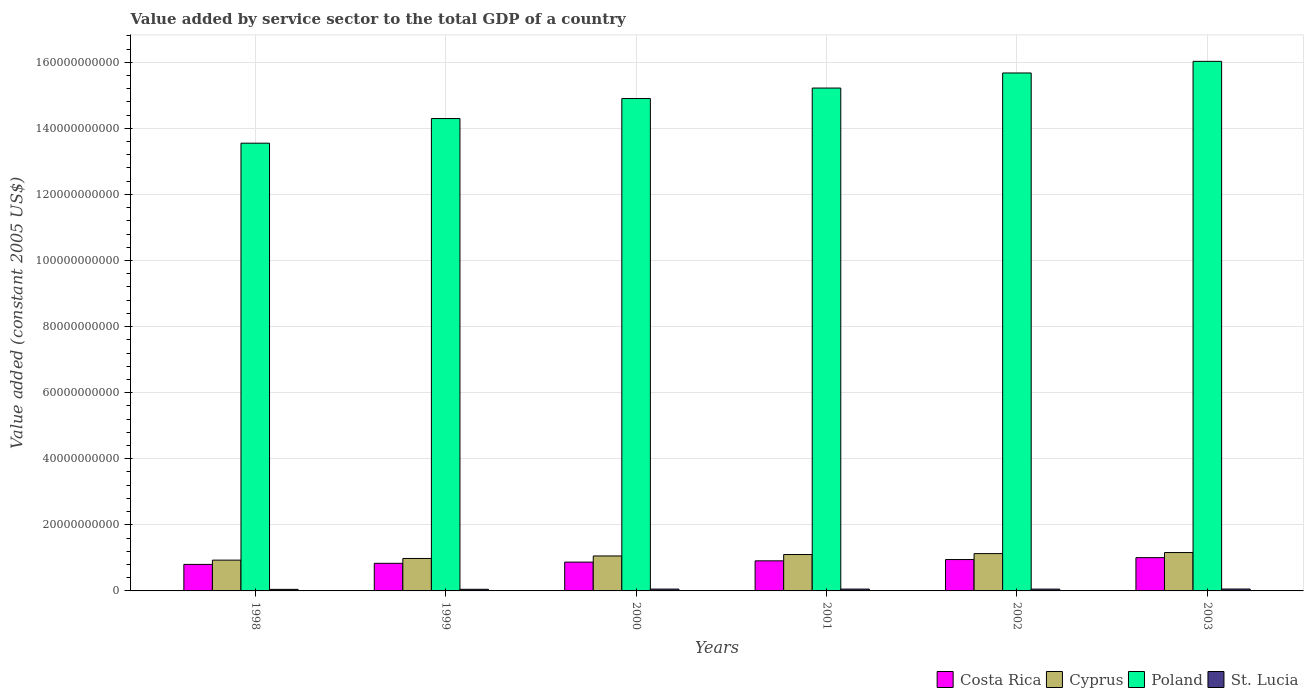Are the number of bars per tick equal to the number of legend labels?
Your answer should be compact. Yes. How many bars are there on the 4th tick from the left?
Ensure brevity in your answer.  4. How many bars are there on the 2nd tick from the right?
Your answer should be very brief. 4. What is the value added by service sector in Costa Rica in 2001?
Your response must be concise. 9.11e+09. Across all years, what is the maximum value added by service sector in Costa Rica?
Give a very brief answer. 1.01e+1. Across all years, what is the minimum value added by service sector in Poland?
Provide a succinct answer. 1.36e+11. In which year was the value added by service sector in Costa Rica minimum?
Your answer should be very brief. 1998. What is the total value added by service sector in Poland in the graph?
Provide a short and direct response. 8.97e+11. What is the difference between the value added by service sector in St. Lucia in 2000 and that in 2001?
Your response must be concise. -4.09e+06. What is the difference between the value added by service sector in Costa Rica in 1998 and the value added by service sector in Poland in 2001?
Offer a very short reply. -1.44e+11. What is the average value added by service sector in Costa Rica per year?
Keep it short and to the point. 8.96e+09. In the year 2002, what is the difference between the value added by service sector in St. Lucia and value added by service sector in Costa Rica?
Keep it short and to the point. -8.95e+09. In how many years, is the value added by service sector in St. Lucia greater than 12000000000 US$?
Provide a short and direct response. 0. What is the ratio of the value added by service sector in St. Lucia in 2000 to that in 2002?
Your response must be concise. 1.01. Is the difference between the value added by service sector in St. Lucia in 1999 and 2001 greater than the difference between the value added by service sector in Costa Rica in 1999 and 2001?
Ensure brevity in your answer.  Yes. What is the difference between the highest and the second highest value added by service sector in Costa Rica?
Your answer should be compact. 5.77e+08. What is the difference between the highest and the lowest value added by service sector in Costa Rica?
Your answer should be very brief. 2.04e+09. Is the sum of the value added by service sector in St. Lucia in 1998 and 2000 greater than the maximum value added by service sector in Poland across all years?
Provide a succinct answer. No. What does the 2nd bar from the right in 2003 represents?
Your response must be concise. Poland. How many bars are there?
Offer a very short reply. 24. Are all the bars in the graph horizontal?
Offer a very short reply. No. What is the difference between two consecutive major ticks on the Y-axis?
Your answer should be very brief. 2.00e+1. Are the values on the major ticks of Y-axis written in scientific E-notation?
Your answer should be very brief. No. Where does the legend appear in the graph?
Your answer should be very brief. Bottom right. How many legend labels are there?
Give a very brief answer. 4. What is the title of the graph?
Provide a short and direct response. Value added by service sector to the total GDP of a country. Does "East Asia (all income levels)" appear as one of the legend labels in the graph?
Give a very brief answer. No. What is the label or title of the Y-axis?
Offer a terse response. Value added (constant 2005 US$). What is the Value added (constant 2005 US$) of Costa Rica in 1998?
Your answer should be very brief. 8.03e+09. What is the Value added (constant 2005 US$) in Cyprus in 1998?
Your response must be concise. 9.32e+09. What is the Value added (constant 2005 US$) in Poland in 1998?
Ensure brevity in your answer.  1.36e+11. What is the Value added (constant 2005 US$) in St. Lucia in 1998?
Keep it short and to the point. 4.72e+08. What is the Value added (constant 2005 US$) in Costa Rica in 1999?
Your response must be concise. 8.36e+09. What is the Value added (constant 2005 US$) in Cyprus in 1999?
Provide a short and direct response. 9.83e+09. What is the Value added (constant 2005 US$) of Poland in 1999?
Offer a terse response. 1.43e+11. What is the Value added (constant 2005 US$) of St. Lucia in 1999?
Your answer should be compact. 4.93e+08. What is the Value added (constant 2005 US$) of Costa Rica in 2000?
Provide a succinct answer. 8.72e+09. What is the Value added (constant 2005 US$) of Cyprus in 2000?
Keep it short and to the point. 1.06e+1. What is the Value added (constant 2005 US$) in Poland in 2000?
Give a very brief answer. 1.49e+11. What is the Value added (constant 2005 US$) of St. Lucia in 2000?
Your answer should be compact. 5.53e+08. What is the Value added (constant 2005 US$) in Costa Rica in 2001?
Offer a terse response. 9.11e+09. What is the Value added (constant 2005 US$) in Cyprus in 2001?
Offer a terse response. 1.10e+1. What is the Value added (constant 2005 US$) in Poland in 2001?
Your answer should be very brief. 1.52e+11. What is the Value added (constant 2005 US$) in St. Lucia in 2001?
Offer a very short reply. 5.57e+08. What is the Value added (constant 2005 US$) of Costa Rica in 2002?
Give a very brief answer. 9.49e+09. What is the Value added (constant 2005 US$) of Cyprus in 2002?
Your response must be concise. 1.13e+1. What is the Value added (constant 2005 US$) in Poland in 2002?
Keep it short and to the point. 1.57e+11. What is the Value added (constant 2005 US$) in St. Lucia in 2002?
Your response must be concise. 5.46e+08. What is the Value added (constant 2005 US$) in Costa Rica in 2003?
Your answer should be very brief. 1.01e+1. What is the Value added (constant 2005 US$) of Cyprus in 2003?
Provide a short and direct response. 1.16e+1. What is the Value added (constant 2005 US$) of Poland in 2003?
Your response must be concise. 1.60e+11. What is the Value added (constant 2005 US$) in St. Lucia in 2003?
Offer a very short reply. 5.74e+08. Across all years, what is the maximum Value added (constant 2005 US$) in Costa Rica?
Your response must be concise. 1.01e+1. Across all years, what is the maximum Value added (constant 2005 US$) of Cyprus?
Your answer should be compact. 1.16e+1. Across all years, what is the maximum Value added (constant 2005 US$) in Poland?
Offer a very short reply. 1.60e+11. Across all years, what is the maximum Value added (constant 2005 US$) of St. Lucia?
Ensure brevity in your answer.  5.74e+08. Across all years, what is the minimum Value added (constant 2005 US$) in Costa Rica?
Provide a short and direct response. 8.03e+09. Across all years, what is the minimum Value added (constant 2005 US$) of Cyprus?
Give a very brief answer. 9.32e+09. Across all years, what is the minimum Value added (constant 2005 US$) of Poland?
Offer a terse response. 1.36e+11. Across all years, what is the minimum Value added (constant 2005 US$) of St. Lucia?
Ensure brevity in your answer.  4.72e+08. What is the total Value added (constant 2005 US$) in Costa Rica in the graph?
Offer a terse response. 5.38e+1. What is the total Value added (constant 2005 US$) in Cyprus in the graph?
Provide a short and direct response. 6.36e+1. What is the total Value added (constant 2005 US$) in Poland in the graph?
Your answer should be compact. 8.97e+11. What is the total Value added (constant 2005 US$) of St. Lucia in the graph?
Your answer should be compact. 3.20e+09. What is the difference between the Value added (constant 2005 US$) in Costa Rica in 1998 and that in 1999?
Your answer should be compact. -3.30e+08. What is the difference between the Value added (constant 2005 US$) in Cyprus in 1998 and that in 1999?
Your response must be concise. -5.08e+08. What is the difference between the Value added (constant 2005 US$) of Poland in 1998 and that in 1999?
Your response must be concise. -7.45e+09. What is the difference between the Value added (constant 2005 US$) of St. Lucia in 1998 and that in 1999?
Provide a succinct answer. -2.10e+07. What is the difference between the Value added (constant 2005 US$) in Costa Rica in 1998 and that in 2000?
Offer a terse response. -6.91e+08. What is the difference between the Value added (constant 2005 US$) in Cyprus in 1998 and that in 2000?
Offer a very short reply. -1.26e+09. What is the difference between the Value added (constant 2005 US$) in Poland in 1998 and that in 2000?
Your response must be concise. -1.35e+1. What is the difference between the Value added (constant 2005 US$) of St. Lucia in 1998 and that in 2000?
Keep it short and to the point. -8.11e+07. What is the difference between the Value added (constant 2005 US$) in Costa Rica in 1998 and that in 2001?
Give a very brief answer. -1.08e+09. What is the difference between the Value added (constant 2005 US$) in Cyprus in 1998 and that in 2001?
Make the answer very short. -1.70e+09. What is the difference between the Value added (constant 2005 US$) of Poland in 1998 and that in 2001?
Give a very brief answer. -1.67e+1. What is the difference between the Value added (constant 2005 US$) in St. Lucia in 1998 and that in 2001?
Keep it short and to the point. -8.52e+07. What is the difference between the Value added (constant 2005 US$) in Costa Rica in 1998 and that in 2002?
Your answer should be very brief. -1.46e+09. What is the difference between the Value added (constant 2005 US$) in Cyprus in 1998 and that in 2002?
Offer a terse response. -1.98e+09. What is the difference between the Value added (constant 2005 US$) of Poland in 1998 and that in 2002?
Your answer should be very brief. -2.12e+1. What is the difference between the Value added (constant 2005 US$) in St. Lucia in 1998 and that in 2002?
Your answer should be very brief. -7.44e+07. What is the difference between the Value added (constant 2005 US$) in Costa Rica in 1998 and that in 2003?
Offer a terse response. -2.04e+09. What is the difference between the Value added (constant 2005 US$) in Cyprus in 1998 and that in 2003?
Provide a succinct answer. -2.30e+09. What is the difference between the Value added (constant 2005 US$) of Poland in 1998 and that in 2003?
Your answer should be compact. -2.48e+1. What is the difference between the Value added (constant 2005 US$) in St. Lucia in 1998 and that in 2003?
Your response must be concise. -1.02e+08. What is the difference between the Value added (constant 2005 US$) in Costa Rica in 1999 and that in 2000?
Your answer should be very brief. -3.61e+08. What is the difference between the Value added (constant 2005 US$) of Cyprus in 1999 and that in 2000?
Offer a very short reply. -7.54e+08. What is the difference between the Value added (constant 2005 US$) in Poland in 1999 and that in 2000?
Keep it short and to the point. -6.06e+09. What is the difference between the Value added (constant 2005 US$) in St. Lucia in 1999 and that in 2000?
Offer a terse response. -6.01e+07. What is the difference between the Value added (constant 2005 US$) of Costa Rica in 1999 and that in 2001?
Ensure brevity in your answer.  -7.47e+08. What is the difference between the Value added (constant 2005 US$) of Cyprus in 1999 and that in 2001?
Give a very brief answer. -1.19e+09. What is the difference between the Value added (constant 2005 US$) in Poland in 1999 and that in 2001?
Keep it short and to the point. -9.23e+09. What is the difference between the Value added (constant 2005 US$) in St. Lucia in 1999 and that in 2001?
Give a very brief answer. -6.42e+07. What is the difference between the Value added (constant 2005 US$) of Costa Rica in 1999 and that in 2002?
Your answer should be compact. -1.13e+09. What is the difference between the Value added (constant 2005 US$) in Cyprus in 1999 and that in 2002?
Your answer should be very brief. -1.47e+09. What is the difference between the Value added (constant 2005 US$) of Poland in 1999 and that in 2002?
Provide a short and direct response. -1.38e+1. What is the difference between the Value added (constant 2005 US$) in St. Lucia in 1999 and that in 2002?
Provide a short and direct response. -5.34e+07. What is the difference between the Value added (constant 2005 US$) in Costa Rica in 1999 and that in 2003?
Offer a very short reply. -1.71e+09. What is the difference between the Value added (constant 2005 US$) in Cyprus in 1999 and that in 2003?
Offer a terse response. -1.79e+09. What is the difference between the Value added (constant 2005 US$) in Poland in 1999 and that in 2003?
Provide a short and direct response. -1.73e+1. What is the difference between the Value added (constant 2005 US$) in St. Lucia in 1999 and that in 2003?
Provide a short and direct response. -8.07e+07. What is the difference between the Value added (constant 2005 US$) in Costa Rica in 2000 and that in 2001?
Your answer should be compact. -3.86e+08. What is the difference between the Value added (constant 2005 US$) of Cyprus in 2000 and that in 2001?
Give a very brief answer. -4.37e+08. What is the difference between the Value added (constant 2005 US$) in Poland in 2000 and that in 2001?
Your answer should be very brief. -3.17e+09. What is the difference between the Value added (constant 2005 US$) in St. Lucia in 2000 and that in 2001?
Your response must be concise. -4.09e+06. What is the difference between the Value added (constant 2005 US$) in Costa Rica in 2000 and that in 2002?
Give a very brief answer. -7.73e+08. What is the difference between the Value added (constant 2005 US$) of Cyprus in 2000 and that in 2002?
Keep it short and to the point. -7.16e+08. What is the difference between the Value added (constant 2005 US$) in Poland in 2000 and that in 2002?
Provide a short and direct response. -7.74e+09. What is the difference between the Value added (constant 2005 US$) in St. Lucia in 2000 and that in 2002?
Your response must be concise. 6.70e+06. What is the difference between the Value added (constant 2005 US$) of Costa Rica in 2000 and that in 2003?
Your response must be concise. -1.35e+09. What is the difference between the Value added (constant 2005 US$) of Cyprus in 2000 and that in 2003?
Offer a terse response. -1.04e+09. What is the difference between the Value added (constant 2005 US$) in Poland in 2000 and that in 2003?
Make the answer very short. -1.13e+1. What is the difference between the Value added (constant 2005 US$) in St. Lucia in 2000 and that in 2003?
Your answer should be very brief. -2.07e+07. What is the difference between the Value added (constant 2005 US$) of Costa Rica in 2001 and that in 2002?
Keep it short and to the point. -3.86e+08. What is the difference between the Value added (constant 2005 US$) in Cyprus in 2001 and that in 2002?
Give a very brief answer. -2.79e+08. What is the difference between the Value added (constant 2005 US$) of Poland in 2001 and that in 2002?
Provide a short and direct response. -4.56e+09. What is the difference between the Value added (constant 2005 US$) of St. Lucia in 2001 and that in 2002?
Offer a very short reply. 1.08e+07. What is the difference between the Value added (constant 2005 US$) in Costa Rica in 2001 and that in 2003?
Keep it short and to the point. -9.63e+08. What is the difference between the Value added (constant 2005 US$) of Cyprus in 2001 and that in 2003?
Your answer should be compact. -6.00e+08. What is the difference between the Value added (constant 2005 US$) in Poland in 2001 and that in 2003?
Make the answer very short. -8.08e+09. What is the difference between the Value added (constant 2005 US$) of St. Lucia in 2001 and that in 2003?
Keep it short and to the point. -1.66e+07. What is the difference between the Value added (constant 2005 US$) of Costa Rica in 2002 and that in 2003?
Provide a short and direct response. -5.77e+08. What is the difference between the Value added (constant 2005 US$) in Cyprus in 2002 and that in 2003?
Your answer should be very brief. -3.21e+08. What is the difference between the Value added (constant 2005 US$) in Poland in 2002 and that in 2003?
Ensure brevity in your answer.  -3.52e+09. What is the difference between the Value added (constant 2005 US$) of St. Lucia in 2002 and that in 2003?
Your answer should be very brief. -2.74e+07. What is the difference between the Value added (constant 2005 US$) in Costa Rica in 1998 and the Value added (constant 2005 US$) in Cyprus in 1999?
Provide a short and direct response. -1.80e+09. What is the difference between the Value added (constant 2005 US$) in Costa Rica in 1998 and the Value added (constant 2005 US$) in Poland in 1999?
Your answer should be very brief. -1.35e+11. What is the difference between the Value added (constant 2005 US$) of Costa Rica in 1998 and the Value added (constant 2005 US$) of St. Lucia in 1999?
Make the answer very short. 7.54e+09. What is the difference between the Value added (constant 2005 US$) in Cyprus in 1998 and the Value added (constant 2005 US$) in Poland in 1999?
Ensure brevity in your answer.  -1.34e+11. What is the difference between the Value added (constant 2005 US$) of Cyprus in 1998 and the Value added (constant 2005 US$) of St. Lucia in 1999?
Provide a short and direct response. 8.82e+09. What is the difference between the Value added (constant 2005 US$) in Poland in 1998 and the Value added (constant 2005 US$) in St. Lucia in 1999?
Make the answer very short. 1.35e+11. What is the difference between the Value added (constant 2005 US$) in Costa Rica in 1998 and the Value added (constant 2005 US$) in Cyprus in 2000?
Offer a terse response. -2.55e+09. What is the difference between the Value added (constant 2005 US$) in Costa Rica in 1998 and the Value added (constant 2005 US$) in Poland in 2000?
Offer a very short reply. -1.41e+11. What is the difference between the Value added (constant 2005 US$) of Costa Rica in 1998 and the Value added (constant 2005 US$) of St. Lucia in 2000?
Offer a very short reply. 7.48e+09. What is the difference between the Value added (constant 2005 US$) in Cyprus in 1998 and the Value added (constant 2005 US$) in Poland in 2000?
Offer a very short reply. -1.40e+11. What is the difference between the Value added (constant 2005 US$) in Cyprus in 1998 and the Value added (constant 2005 US$) in St. Lucia in 2000?
Make the answer very short. 8.76e+09. What is the difference between the Value added (constant 2005 US$) of Poland in 1998 and the Value added (constant 2005 US$) of St. Lucia in 2000?
Provide a succinct answer. 1.35e+11. What is the difference between the Value added (constant 2005 US$) in Costa Rica in 1998 and the Value added (constant 2005 US$) in Cyprus in 2001?
Your answer should be very brief. -2.99e+09. What is the difference between the Value added (constant 2005 US$) of Costa Rica in 1998 and the Value added (constant 2005 US$) of Poland in 2001?
Give a very brief answer. -1.44e+11. What is the difference between the Value added (constant 2005 US$) of Costa Rica in 1998 and the Value added (constant 2005 US$) of St. Lucia in 2001?
Offer a terse response. 7.47e+09. What is the difference between the Value added (constant 2005 US$) of Cyprus in 1998 and the Value added (constant 2005 US$) of Poland in 2001?
Your response must be concise. -1.43e+11. What is the difference between the Value added (constant 2005 US$) of Cyprus in 1998 and the Value added (constant 2005 US$) of St. Lucia in 2001?
Your response must be concise. 8.76e+09. What is the difference between the Value added (constant 2005 US$) in Poland in 1998 and the Value added (constant 2005 US$) in St. Lucia in 2001?
Provide a short and direct response. 1.35e+11. What is the difference between the Value added (constant 2005 US$) of Costa Rica in 1998 and the Value added (constant 2005 US$) of Cyprus in 2002?
Your response must be concise. -3.27e+09. What is the difference between the Value added (constant 2005 US$) of Costa Rica in 1998 and the Value added (constant 2005 US$) of Poland in 2002?
Provide a succinct answer. -1.49e+11. What is the difference between the Value added (constant 2005 US$) in Costa Rica in 1998 and the Value added (constant 2005 US$) in St. Lucia in 2002?
Provide a succinct answer. 7.48e+09. What is the difference between the Value added (constant 2005 US$) in Cyprus in 1998 and the Value added (constant 2005 US$) in Poland in 2002?
Offer a terse response. -1.47e+11. What is the difference between the Value added (constant 2005 US$) in Cyprus in 1998 and the Value added (constant 2005 US$) in St. Lucia in 2002?
Your answer should be very brief. 8.77e+09. What is the difference between the Value added (constant 2005 US$) of Poland in 1998 and the Value added (constant 2005 US$) of St. Lucia in 2002?
Provide a succinct answer. 1.35e+11. What is the difference between the Value added (constant 2005 US$) in Costa Rica in 1998 and the Value added (constant 2005 US$) in Cyprus in 2003?
Offer a very short reply. -3.59e+09. What is the difference between the Value added (constant 2005 US$) of Costa Rica in 1998 and the Value added (constant 2005 US$) of Poland in 2003?
Give a very brief answer. -1.52e+11. What is the difference between the Value added (constant 2005 US$) in Costa Rica in 1998 and the Value added (constant 2005 US$) in St. Lucia in 2003?
Provide a short and direct response. 7.46e+09. What is the difference between the Value added (constant 2005 US$) in Cyprus in 1998 and the Value added (constant 2005 US$) in Poland in 2003?
Offer a very short reply. -1.51e+11. What is the difference between the Value added (constant 2005 US$) in Cyprus in 1998 and the Value added (constant 2005 US$) in St. Lucia in 2003?
Provide a succinct answer. 8.74e+09. What is the difference between the Value added (constant 2005 US$) of Poland in 1998 and the Value added (constant 2005 US$) of St. Lucia in 2003?
Offer a terse response. 1.35e+11. What is the difference between the Value added (constant 2005 US$) in Costa Rica in 1999 and the Value added (constant 2005 US$) in Cyprus in 2000?
Provide a succinct answer. -2.22e+09. What is the difference between the Value added (constant 2005 US$) in Costa Rica in 1999 and the Value added (constant 2005 US$) in Poland in 2000?
Your answer should be compact. -1.41e+11. What is the difference between the Value added (constant 2005 US$) in Costa Rica in 1999 and the Value added (constant 2005 US$) in St. Lucia in 2000?
Provide a short and direct response. 7.81e+09. What is the difference between the Value added (constant 2005 US$) in Cyprus in 1999 and the Value added (constant 2005 US$) in Poland in 2000?
Ensure brevity in your answer.  -1.39e+11. What is the difference between the Value added (constant 2005 US$) of Cyprus in 1999 and the Value added (constant 2005 US$) of St. Lucia in 2000?
Offer a very short reply. 9.27e+09. What is the difference between the Value added (constant 2005 US$) in Poland in 1999 and the Value added (constant 2005 US$) in St. Lucia in 2000?
Make the answer very short. 1.42e+11. What is the difference between the Value added (constant 2005 US$) of Costa Rica in 1999 and the Value added (constant 2005 US$) of Cyprus in 2001?
Keep it short and to the point. -2.66e+09. What is the difference between the Value added (constant 2005 US$) in Costa Rica in 1999 and the Value added (constant 2005 US$) in Poland in 2001?
Make the answer very short. -1.44e+11. What is the difference between the Value added (constant 2005 US$) of Costa Rica in 1999 and the Value added (constant 2005 US$) of St. Lucia in 2001?
Ensure brevity in your answer.  7.80e+09. What is the difference between the Value added (constant 2005 US$) in Cyprus in 1999 and the Value added (constant 2005 US$) in Poland in 2001?
Your response must be concise. -1.42e+11. What is the difference between the Value added (constant 2005 US$) in Cyprus in 1999 and the Value added (constant 2005 US$) in St. Lucia in 2001?
Offer a very short reply. 9.27e+09. What is the difference between the Value added (constant 2005 US$) in Poland in 1999 and the Value added (constant 2005 US$) in St. Lucia in 2001?
Your response must be concise. 1.42e+11. What is the difference between the Value added (constant 2005 US$) in Costa Rica in 1999 and the Value added (constant 2005 US$) in Cyprus in 2002?
Offer a terse response. -2.94e+09. What is the difference between the Value added (constant 2005 US$) in Costa Rica in 1999 and the Value added (constant 2005 US$) in Poland in 2002?
Provide a short and direct response. -1.48e+11. What is the difference between the Value added (constant 2005 US$) in Costa Rica in 1999 and the Value added (constant 2005 US$) in St. Lucia in 2002?
Give a very brief answer. 7.81e+09. What is the difference between the Value added (constant 2005 US$) in Cyprus in 1999 and the Value added (constant 2005 US$) in Poland in 2002?
Give a very brief answer. -1.47e+11. What is the difference between the Value added (constant 2005 US$) in Cyprus in 1999 and the Value added (constant 2005 US$) in St. Lucia in 2002?
Your answer should be very brief. 9.28e+09. What is the difference between the Value added (constant 2005 US$) in Poland in 1999 and the Value added (constant 2005 US$) in St. Lucia in 2002?
Keep it short and to the point. 1.42e+11. What is the difference between the Value added (constant 2005 US$) in Costa Rica in 1999 and the Value added (constant 2005 US$) in Cyprus in 2003?
Your answer should be compact. -3.26e+09. What is the difference between the Value added (constant 2005 US$) in Costa Rica in 1999 and the Value added (constant 2005 US$) in Poland in 2003?
Make the answer very short. -1.52e+11. What is the difference between the Value added (constant 2005 US$) in Costa Rica in 1999 and the Value added (constant 2005 US$) in St. Lucia in 2003?
Give a very brief answer. 7.79e+09. What is the difference between the Value added (constant 2005 US$) in Cyprus in 1999 and the Value added (constant 2005 US$) in Poland in 2003?
Give a very brief answer. -1.50e+11. What is the difference between the Value added (constant 2005 US$) in Cyprus in 1999 and the Value added (constant 2005 US$) in St. Lucia in 2003?
Provide a succinct answer. 9.25e+09. What is the difference between the Value added (constant 2005 US$) of Poland in 1999 and the Value added (constant 2005 US$) of St. Lucia in 2003?
Offer a terse response. 1.42e+11. What is the difference between the Value added (constant 2005 US$) of Costa Rica in 2000 and the Value added (constant 2005 US$) of Cyprus in 2001?
Keep it short and to the point. -2.30e+09. What is the difference between the Value added (constant 2005 US$) in Costa Rica in 2000 and the Value added (constant 2005 US$) in Poland in 2001?
Offer a very short reply. -1.43e+11. What is the difference between the Value added (constant 2005 US$) in Costa Rica in 2000 and the Value added (constant 2005 US$) in St. Lucia in 2001?
Your answer should be very brief. 8.16e+09. What is the difference between the Value added (constant 2005 US$) of Cyprus in 2000 and the Value added (constant 2005 US$) of Poland in 2001?
Your response must be concise. -1.42e+11. What is the difference between the Value added (constant 2005 US$) in Cyprus in 2000 and the Value added (constant 2005 US$) in St. Lucia in 2001?
Provide a succinct answer. 1.00e+1. What is the difference between the Value added (constant 2005 US$) of Poland in 2000 and the Value added (constant 2005 US$) of St. Lucia in 2001?
Keep it short and to the point. 1.48e+11. What is the difference between the Value added (constant 2005 US$) in Costa Rica in 2000 and the Value added (constant 2005 US$) in Cyprus in 2002?
Your response must be concise. -2.57e+09. What is the difference between the Value added (constant 2005 US$) of Costa Rica in 2000 and the Value added (constant 2005 US$) of Poland in 2002?
Keep it short and to the point. -1.48e+11. What is the difference between the Value added (constant 2005 US$) of Costa Rica in 2000 and the Value added (constant 2005 US$) of St. Lucia in 2002?
Provide a short and direct response. 8.17e+09. What is the difference between the Value added (constant 2005 US$) of Cyprus in 2000 and the Value added (constant 2005 US$) of Poland in 2002?
Make the answer very short. -1.46e+11. What is the difference between the Value added (constant 2005 US$) of Cyprus in 2000 and the Value added (constant 2005 US$) of St. Lucia in 2002?
Provide a short and direct response. 1.00e+1. What is the difference between the Value added (constant 2005 US$) in Poland in 2000 and the Value added (constant 2005 US$) in St. Lucia in 2002?
Provide a succinct answer. 1.48e+11. What is the difference between the Value added (constant 2005 US$) of Costa Rica in 2000 and the Value added (constant 2005 US$) of Cyprus in 2003?
Make the answer very short. -2.90e+09. What is the difference between the Value added (constant 2005 US$) of Costa Rica in 2000 and the Value added (constant 2005 US$) of Poland in 2003?
Your response must be concise. -1.52e+11. What is the difference between the Value added (constant 2005 US$) in Costa Rica in 2000 and the Value added (constant 2005 US$) in St. Lucia in 2003?
Your response must be concise. 8.15e+09. What is the difference between the Value added (constant 2005 US$) of Cyprus in 2000 and the Value added (constant 2005 US$) of Poland in 2003?
Keep it short and to the point. -1.50e+11. What is the difference between the Value added (constant 2005 US$) in Cyprus in 2000 and the Value added (constant 2005 US$) in St. Lucia in 2003?
Ensure brevity in your answer.  1.00e+1. What is the difference between the Value added (constant 2005 US$) of Poland in 2000 and the Value added (constant 2005 US$) of St. Lucia in 2003?
Offer a terse response. 1.48e+11. What is the difference between the Value added (constant 2005 US$) in Costa Rica in 2001 and the Value added (constant 2005 US$) in Cyprus in 2002?
Give a very brief answer. -2.19e+09. What is the difference between the Value added (constant 2005 US$) in Costa Rica in 2001 and the Value added (constant 2005 US$) in Poland in 2002?
Make the answer very short. -1.48e+11. What is the difference between the Value added (constant 2005 US$) of Costa Rica in 2001 and the Value added (constant 2005 US$) of St. Lucia in 2002?
Provide a succinct answer. 8.56e+09. What is the difference between the Value added (constant 2005 US$) of Cyprus in 2001 and the Value added (constant 2005 US$) of Poland in 2002?
Your response must be concise. -1.46e+11. What is the difference between the Value added (constant 2005 US$) of Cyprus in 2001 and the Value added (constant 2005 US$) of St. Lucia in 2002?
Ensure brevity in your answer.  1.05e+1. What is the difference between the Value added (constant 2005 US$) of Poland in 2001 and the Value added (constant 2005 US$) of St. Lucia in 2002?
Provide a short and direct response. 1.52e+11. What is the difference between the Value added (constant 2005 US$) of Costa Rica in 2001 and the Value added (constant 2005 US$) of Cyprus in 2003?
Keep it short and to the point. -2.51e+09. What is the difference between the Value added (constant 2005 US$) of Costa Rica in 2001 and the Value added (constant 2005 US$) of Poland in 2003?
Offer a very short reply. -1.51e+11. What is the difference between the Value added (constant 2005 US$) in Costa Rica in 2001 and the Value added (constant 2005 US$) in St. Lucia in 2003?
Your answer should be compact. 8.53e+09. What is the difference between the Value added (constant 2005 US$) of Cyprus in 2001 and the Value added (constant 2005 US$) of Poland in 2003?
Make the answer very short. -1.49e+11. What is the difference between the Value added (constant 2005 US$) in Cyprus in 2001 and the Value added (constant 2005 US$) in St. Lucia in 2003?
Ensure brevity in your answer.  1.04e+1. What is the difference between the Value added (constant 2005 US$) in Poland in 2001 and the Value added (constant 2005 US$) in St. Lucia in 2003?
Keep it short and to the point. 1.52e+11. What is the difference between the Value added (constant 2005 US$) of Costa Rica in 2002 and the Value added (constant 2005 US$) of Cyprus in 2003?
Your response must be concise. -2.12e+09. What is the difference between the Value added (constant 2005 US$) of Costa Rica in 2002 and the Value added (constant 2005 US$) of Poland in 2003?
Make the answer very short. -1.51e+11. What is the difference between the Value added (constant 2005 US$) of Costa Rica in 2002 and the Value added (constant 2005 US$) of St. Lucia in 2003?
Offer a very short reply. 8.92e+09. What is the difference between the Value added (constant 2005 US$) in Cyprus in 2002 and the Value added (constant 2005 US$) in Poland in 2003?
Your answer should be compact. -1.49e+11. What is the difference between the Value added (constant 2005 US$) of Cyprus in 2002 and the Value added (constant 2005 US$) of St. Lucia in 2003?
Keep it short and to the point. 1.07e+1. What is the difference between the Value added (constant 2005 US$) in Poland in 2002 and the Value added (constant 2005 US$) in St. Lucia in 2003?
Provide a succinct answer. 1.56e+11. What is the average Value added (constant 2005 US$) of Costa Rica per year?
Your answer should be compact. 8.96e+09. What is the average Value added (constant 2005 US$) of Cyprus per year?
Your answer should be compact. 1.06e+1. What is the average Value added (constant 2005 US$) in Poland per year?
Give a very brief answer. 1.49e+11. What is the average Value added (constant 2005 US$) in St. Lucia per year?
Make the answer very short. 5.33e+08. In the year 1998, what is the difference between the Value added (constant 2005 US$) in Costa Rica and Value added (constant 2005 US$) in Cyprus?
Make the answer very short. -1.29e+09. In the year 1998, what is the difference between the Value added (constant 2005 US$) in Costa Rica and Value added (constant 2005 US$) in Poland?
Your answer should be compact. -1.27e+11. In the year 1998, what is the difference between the Value added (constant 2005 US$) in Costa Rica and Value added (constant 2005 US$) in St. Lucia?
Offer a very short reply. 7.56e+09. In the year 1998, what is the difference between the Value added (constant 2005 US$) in Cyprus and Value added (constant 2005 US$) in Poland?
Give a very brief answer. -1.26e+11. In the year 1998, what is the difference between the Value added (constant 2005 US$) of Cyprus and Value added (constant 2005 US$) of St. Lucia?
Provide a short and direct response. 8.84e+09. In the year 1998, what is the difference between the Value added (constant 2005 US$) of Poland and Value added (constant 2005 US$) of St. Lucia?
Provide a short and direct response. 1.35e+11. In the year 1999, what is the difference between the Value added (constant 2005 US$) of Costa Rica and Value added (constant 2005 US$) of Cyprus?
Your answer should be very brief. -1.47e+09. In the year 1999, what is the difference between the Value added (constant 2005 US$) in Costa Rica and Value added (constant 2005 US$) in Poland?
Keep it short and to the point. -1.35e+11. In the year 1999, what is the difference between the Value added (constant 2005 US$) in Costa Rica and Value added (constant 2005 US$) in St. Lucia?
Keep it short and to the point. 7.87e+09. In the year 1999, what is the difference between the Value added (constant 2005 US$) of Cyprus and Value added (constant 2005 US$) of Poland?
Make the answer very short. -1.33e+11. In the year 1999, what is the difference between the Value added (constant 2005 US$) in Cyprus and Value added (constant 2005 US$) in St. Lucia?
Provide a succinct answer. 9.33e+09. In the year 1999, what is the difference between the Value added (constant 2005 US$) of Poland and Value added (constant 2005 US$) of St. Lucia?
Ensure brevity in your answer.  1.42e+11. In the year 2000, what is the difference between the Value added (constant 2005 US$) in Costa Rica and Value added (constant 2005 US$) in Cyprus?
Provide a succinct answer. -1.86e+09. In the year 2000, what is the difference between the Value added (constant 2005 US$) of Costa Rica and Value added (constant 2005 US$) of Poland?
Your answer should be very brief. -1.40e+11. In the year 2000, what is the difference between the Value added (constant 2005 US$) in Costa Rica and Value added (constant 2005 US$) in St. Lucia?
Offer a very short reply. 8.17e+09. In the year 2000, what is the difference between the Value added (constant 2005 US$) of Cyprus and Value added (constant 2005 US$) of Poland?
Your answer should be very brief. -1.38e+11. In the year 2000, what is the difference between the Value added (constant 2005 US$) in Cyprus and Value added (constant 2005 US$) in St. Lucia?
Ensure brevity in your answer.  1.00e+1. In the year 2000, what is the difference between the Value added (constant 2005 US$) of Poland and Value added (constant 2005 US$) of St. Lucia?
Ensure brevity in your answer.  1.48e+11. In the year 2001, what is the difference between the Value added (constant 2005 US$) of Costa Rica and Value added (constant 2005 US$) of Cyprus?
Ensure brevity in your answer.  -1.91e+09. In the year 2001, what is the difference between the Value added (constant 2005 US$) of Costa Rica and Value added (constant 2005 US$) of Poland?
Provide a short and direct response. -1.43e+11. In the year 2001, what is the difference between the Value added (constant 2005 US$) of Costa Rica and Value added (constant 2005 US$) of St. Lucia?
Ensure brevity in your answer.  8.55e+09. In the year 2001, what is the difference between the Value added (constant 2005 US$) in Cyprus and Value added (constant 2005 US$) in Poland?
Offer a very short reply. -1.41e+11. In the year 2001, what is the difference between the Value added (constant 2005 US$) in Cyprus and Value added (constant 2005 US$) in St. Lucia?
Give a very brief answer. 1.05e+1. In the year 2001, what is the difference between the Value added (constant 2005 US$) of Poland and Value added (constant 2005 US$) of St. Lucia?
Keep it short and to the point. 1.52e+11. In the year 2002, what is the difference between the Value added (constant 2005 US$) in Costa Rica and Value added (constant 2005 US$) in Cyprus?
Keep it short and to the point. -1.80e+09. In the year 2002, what is the difference between the Value added (constant 2005 US$) of Costa Rica and Value added (constant 2005 US$) of Poland?
Offer a very short reply. -1.47e+11. In the year 2002, what is the difference between the Value added (constant 2005 US$) in Costa Rica and Value added (constant 2005 US$) in St. Lucia?
Make the answer very short. 8.95e+09. In the year 2002, what is the difference between the Value added (constant 2005 US$) in Cyprus and Value added (constant 2005 US$) in Poland?
Ensure brevity in your answer.  -1.45e+11. In the year 2002, what is the difference between the Value added (constant 2005 US$) of Cyprus and Value added (constant 2005 US$) of St. Lucia?
Your answer should be very brief. 1.07e+1. In the year 2002, what is the difference between the Value added (constant 2005 US$) in Poland and Value added (constant 2005 US$) in St. Lucia?
Give a very brief answer. 1.56e+11. In the year 2003, what is the difference between the Value added (constant 2005 US$) in Costa Rica and Value added (constant 2005 US$) in Cyprus?
Provide a succinct answer. -1.55e+09. In the year 2003, what is the difference between the Value added (constant 2005 US$) in Costa Rica and Value added (constant 2005 US$) in Poland?
Provide a succinct answer. -1.50e+11. In the year 2003, what is the difference between the Value added (constant 2005 US$) in Costa Rica and Value added (constant 2005 US$) in St. Lucia?
Your answer should be compact. 9.50e+09. In the year 2003, what is the difference between the Value added (constant 2005 US$) in Cyprus and Value added (constant 2005 US$) in Poland?
Keep it short and to the point. -1.49e+11. In the year 2003, what is the difference between the Value added (constant 2005 US$) in Cyprus and Value added (constant 2005 US$) in St. Lucia?
Ensure brevity in your answer.  1.10e+1. In the year 2003, what is the difference between the Value added (constant 2005 US$) in Poland and Value added (constant 2005 US$) in St. Lucia?
Ensure brevity in your answer.  1.60e+11. What is the ratio of the Value added (constant 2005 US$) of Costa Rica in 1998 to that in 1999?
Offer a terse response. 0.96. What is the ratio of the Value added (constant 2005 US$) in Cyprus in 1998 to that in 1999?
Provide a succinct answer. 0.95. What is the ratio of the Value added (constant 2005 US$) of Poland in 1998 to that in 1999?
Make the answer very short. 0.95. What is the ratio of the Value added (constant 2005 US$) of St. Lucia in 1998 to that in 1999?
Your answer should be very brief. 0.96. What is the ratio of the Value added (constant 2005 US$) of Costa Rica in 1998 to that in 2000?
Provide a succinct answer. 0.92. What is the ratio of the Value added (constant 2005 US$) of Cyprus in 1998 to that in 2000?
Your response must be concise. 0.88. What is the ratio of the Value added (constant 2005 US$) of Poland in 1998 to that in 2000?
Give a very brief answer. 0.91. What is the ratio of the Value added (constant 2005 US$) in St. Lucia in 1998 to that in 2000?
Your response must be concise. 0.85. What is the ratio of the Value added (constant 2005 US$) in Costa Rica in 1998 to that in 2001?
Keep it short and to the point. 0.88. What is the ratio of the Value added (constant 2005 US$) of Cyprus in 1998 to that in 2001?
Make the answer very short. 0.85. What is the ratio of the Value added (constant 2005 US$) in Poland in 1998 to that in 2001?
Offer a very short reply. 0.89. What is the ratio of the Value added (constant 2005 US$) in St. Lucia in 1998 to that in 2001?
Your answer should be compact. 0.85. What is the ratio of the Value added (constant 2005 US$) in Costa Rica in 1998 to that in 2002?
Your answer should be very brief. 0.85. What is the ratio of the Value added (constant 2005 US$) in Cyprus in 1998 to that in 2002?
Provide a short and direct response. 0.82. What is the ratio of the Value added (constant 2005 US$) in Poland in 1998 to that in 2002?
Your answer should be very brief. 0.86. What is the ratio of the Value added (constant 2005 US$) in St. Lucia in 1998 to that in 2002?
Offer a very short reply. 0.86. What is the ratio of the Value added (constant 2005 US$) in Costa Rica in 1998 to that in 2003?
Your answer should be compact. 0.8. What is the ratio of the Value added (constant 2005 US$) of Cyprus in 1998 to that in 2003?
Offer a terse response. 0.8. What is the ratio of the Value added (constant 2005 US$) in Poland in 1998 to that in 2003?
Your answer should be compact. 0.85. What is the ratio of the Value added (constant 2005 US$) in St. Lucia in 1998 to that in 2003?
Provide a succinct answer. 0.82. What is the ratio of the Value added (constant 2005 US$) in Costa Rica in 1999 to that in 2000?
Offer a terse response. 0.96. What is the ratio of the Value added (constant 2005 US$) of Cyprus in 1999 to that in 2000?
Your answer should be compact. 0.93. What is the ratio of the Value added (constant 2005 US$) in Poland in 1999 to that in 2000?
Your response must be concise. 0.96. What is the ratio of the Value added (constant 2005 US$) of St. Lucia in 1999 to that in 2000?
Provide a succinct answer. 0.89. What is the ratio of the Value added (constant 2005 US$) of Costa Rica in 1999 to that in 2001?
Your response must be concise. 0.92. What is the ratio of the Value added (constant 2005 US$) of Cyprus in 1999 to that in 2001?
Offer a very short reply. 0.89. What is the ratio of the Value added (constant 2005 US$) of Poland in 1999 to that in 2001?
Keep it short and to the point. 0.94. What is the ratio of the Value added (constant 2005 US$) in St. Lucia in 1999 to that in 2001?
Make the answer very short. 0.88. What is the ratio of the Value added (constant 2005 US$) of Costa Rica in 1999 to that in 2002?
Keep it short and to the point. 0.88. What is the ratio of the Value added (constant 2005 US$) in Cyprus in 1999 to that in 2002?
Give a very brief answer. 0.87. What is the ratio of the Value added (constant 2005 US$) of Poland in 1999 to that in 2002?
Keep it short and to the point. 0.91. What is the ratio of the Value added (constant 2005 US$) of St. Lucia in 1999 to that in 2002?
Ensure brevity in your answer.  0.9. What is the ratio of the Value added (constant 2005 US$) of Costa Rica in 1999 to that in 2003?
Make the answer very short. 0.83. What is the ratio of the Value added (constant 2005 US$) in Cyprus in 1999 to that in 2003?
Provide a short and direct response. 0.85. What is the ratio of the Value added (constant 2005 US$) in Poland in 1999 to that in 2003?
Ensure brevity in your answer.  0.89. What is the ratio of the Value added (constant 2005 US$) in St. Lucia in 1999 to that in 2003?
Provide a short and direct response. 0.86. What is the ratio of the Value added (constant 2005 US$) in Costa Rica in 2000 to that in 2001?
Your answer should be very brief. 0.96. What is the ratio of the Value added (constant 2005 US$) in Cyprus in 2000 to that in 2001?
Ensure brevity in your answer.  0.96. What is the ratio of the Value added (constant 2005 US$) in Poland in 2000 to that in 2001?
Offer a terse response. 0.98. What is the ratio of the Value added (constant 2005 US$) in Costa Rica in 2000 to that in 2002?
Offer a terse response. 0.92. What is the ratio of the Value added (constant 2005 US$) in Cyprus in 2000 to that in 2002?
Ensure brevity in your answer.  0.94. What is the ratio of the Value added (constant 2005 US$) of Poland in 2000 to that in 2002?
Offer a very short reply. 0.95. What is the ratio of the Value added (constant 2005 US$) in St. Lucia in 2000 to that in 2002?
Your answer should be compact. 1.01. What is the ratio of the Value added (constant 2005 US$) of Costa Rica in 2000 to that in 2003?
Offer a very short reply. 0.87. What is the ratio of the Value added (constant 2005 US$) in Cyprus in 2000 to that in 2003?
Give a very brief answer. 0.91. What is the ratio of the Value added (constant 2005 US$) of Poland in 2000 to that in 2003?
Your answer should be very brief. 0.93. What is the ratio of the Value added (constant 2005 US$) of St. Lucia in 2000 to that in 2003?
Your answer should be compact. 0.96. What is the ratio of the Value added (constant 2005 US$) in Costa Rica in 2001 to that in 2002?
Provide a succinct answer. 0.96. What is the ratio of the Value added (constant 2005 US$) in Cyprus in 2001 to that in 2002?
Make the answer very short. 0.98. What is the ratio of the Value added (constant 2005 US$) of Poland in 2001 to that in 2002?
Your response must be concise. 0.97. What is the ratio of the Value added (constant 2005 US$) of St. Lucia in 2001 to that in 2002?
Your answer should be very brief. 1.02. What is the ratio of the Value added (constant 2005 US$) in Costa Rica in 2001 to that in 2003?
Give a very brief answer. 0.9. What is the ratio of the Value added (constant 2005 US$) in Cyprus in 2001 to that in 2003?
Offer a terse response. 0.95. What is the ratio of the Value added (constant 2005 US$) of Poland in 2001 to that in 2003?
Give a very brief answer. 0.95. What is the ratio of the Value added (constant 2005 US$) of St. Lucia in 2001 to that in 2003?
Provide a short and direct response. 0.97. What is the ratio of the Value added (constant 2005 US$) of Costa Rica in 2002 to that in 2003?
Give a very brief answer. 0.94. What is the ratio of the Value added (constant 2005 US$) in Cyprus in 2002 to that in 2003?
Provide a succinct answer. 0.97. What is the ratio of the Value added (constant 2005 US$) of Poland in 2002 to that in 2003?
Your answer should be compact. 0.98. What is the ratio of the Value added (constant 2005 US$) in St. Lucia in 2002 to that in 2003?
Your response must be concise. 0.95. What is the difference between the highest and the second highest Value added (constant 2005 US$) of Costa Rica?
Your response must be concise. 5.77e+08. What is the difference between the highest and the second highest Value added (constant 2005 US$) in Cyprus?
Your answer should be very brief. 3.21e+08. What is the difference between the highest and the second highest Value added (constant 2005 US$) in Poland?
Ensure brevity in your answer.  3.52e+09. What is the difference between the highest and the second highest Value added (constant 2005 US$) of St. Lucia?
Ensure brevity in your answer.  1.66e+07. What is the difference between the highest and the lowest Value added (constant 2005 US$) of Costa Rica?
Your response must be concise. 2.04e+09. What is the difference between the highest and the lowest Value added (constant 2005 US$) of Cyprus?
Keep it short and to the point. 2.30e+09. What is the difference between the highest and the lowest Value added (constant 2005 US$) in Poland?
Ensure brevity in your answer.  2.48e+1. What is the difference between the highest and the lowest Value added (constant 2005 US$) of St. Lucia?
Offer a terse response. 1.02e+08. 